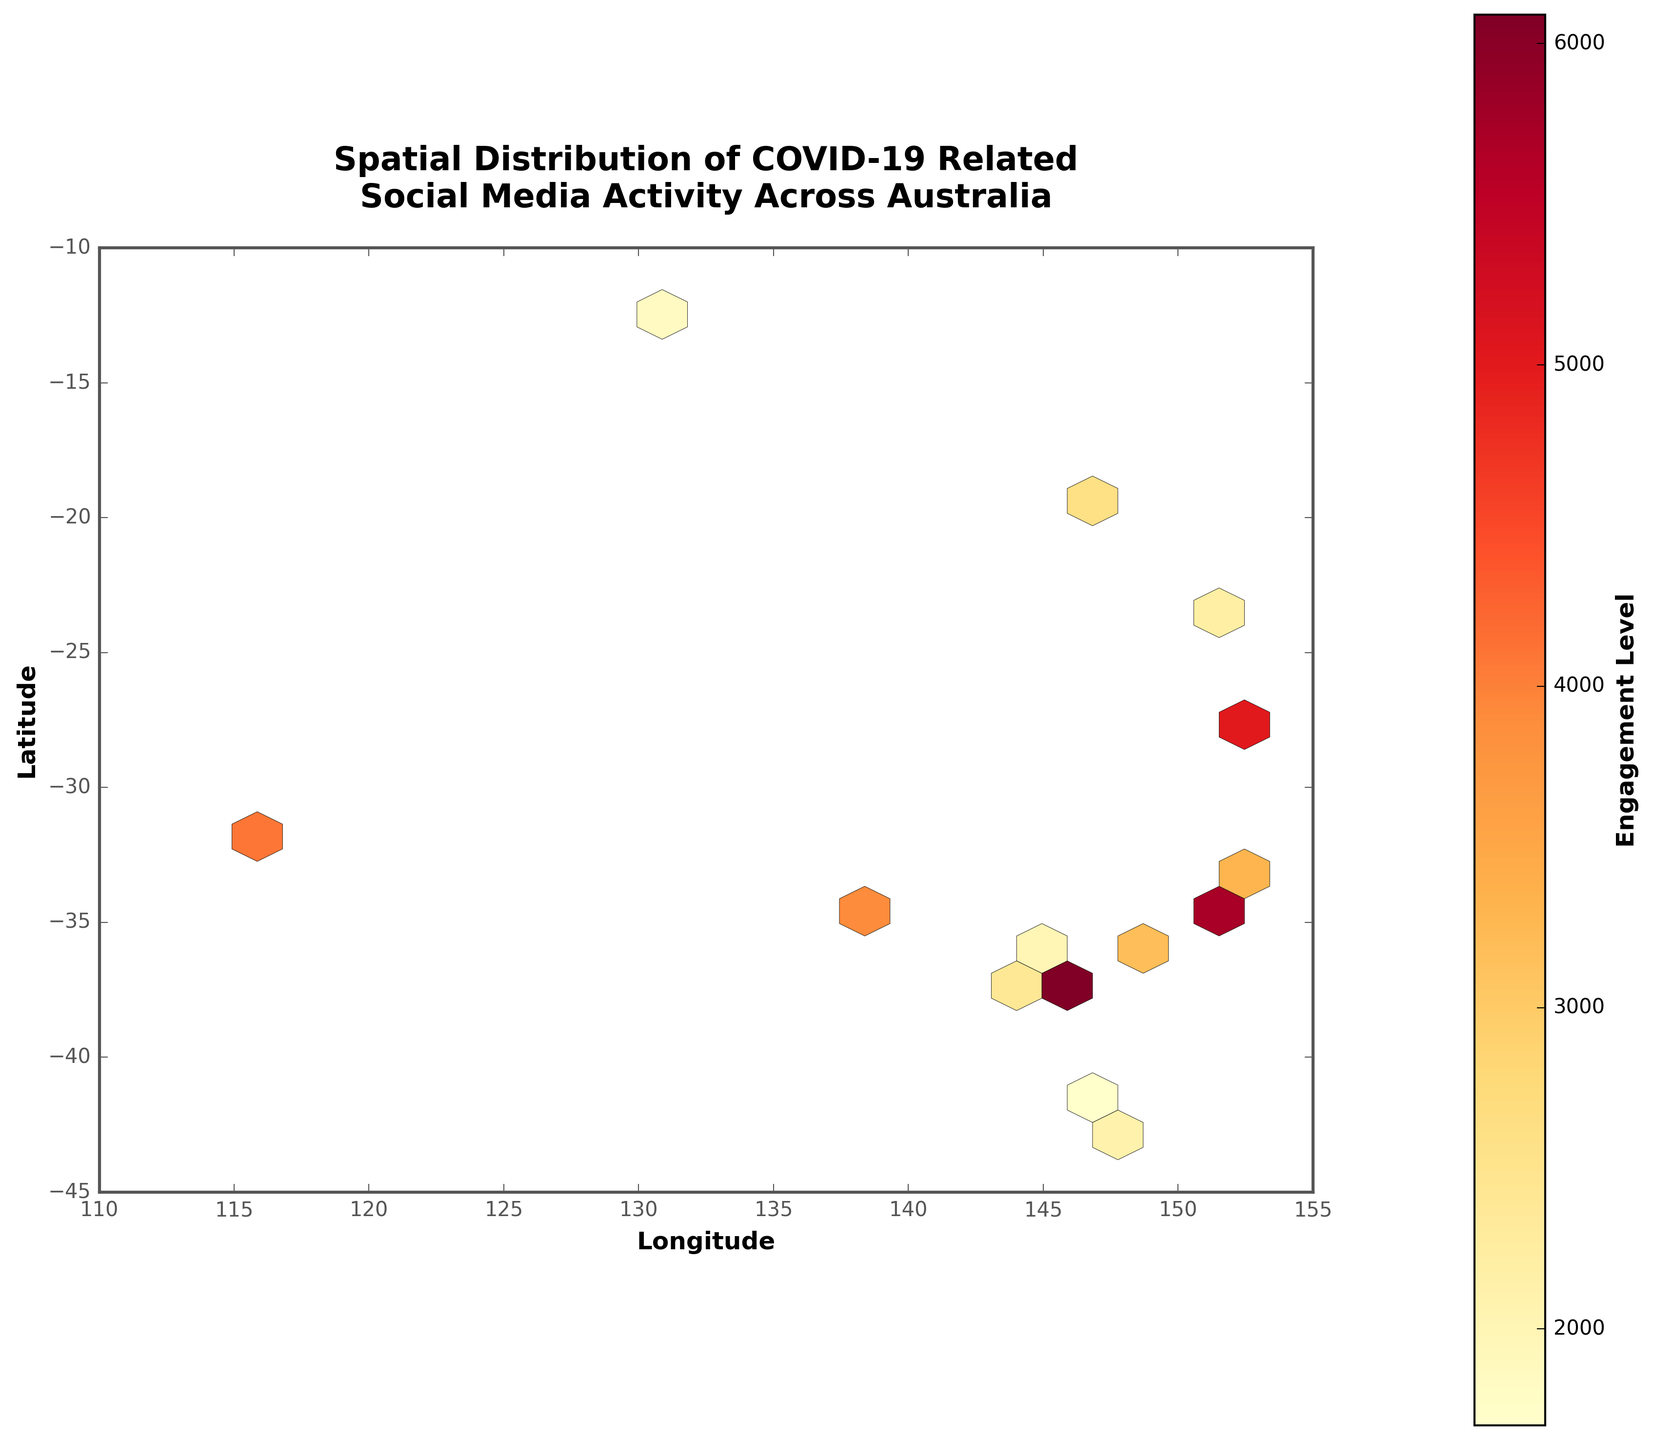What is the title of the plot? The title of the plot is displayed at the top center of the figure, using a larger font size and bold text for emphasis.
Answer: Spatial Distribution of COVID-19 Related Social Media Activity Across Australia What information does the color of the hexagons represent? The color scale represents the engagement levels, with different shades indicating varying levels as denoted by the color bar on the right side of the plot.
Answer: Engagement levels Which latitude and longitude cover the majority of high engagement levels? The highest engagement levels seem to be within the region around Sydney, which corresponds approximately to a latitude of -33.8688 and a longitude of 151.2093.
Answer: Latitude: -33.8688, Longitude: 151.2093 What is the range of the engagement level as shown in the color bar? The range of engagement levels is indicated by the color bar, which transitions from light to dark shades. The lower end is around 1,700 and the upper end is around 8,750.
Answer: 1,700 to 8,750 What does a darker hexagon indicate compared to a lighter hexagon? Darker hexagons represent higher engagement levels, while lighter hexagons represent lower engagement levels, as per the color bar’s gradient.
Answer: Higher engagement levels How many cities show engagement levels higher than 5000? By referring to the engagement levels of individual data points, we identify cities with engagement levels above 5000: Sydney (both entries), Melbourne, Brisbane, and Perth.
Answer: 5 cities Which area has the least engagement level? The area with the least engagement level is represented by the lightest hexagon, located near Darwin with an engagement level of 1850.
Answer: Darwin What similarities can you observe between the cities of Melbourne and Sydney in terms of engagement distribution on the plot? Both Melbourne and Sydney have multiple hexagons indicating high engagement levels, suggesting these cities have similar strong engagement distributions.
Answer: High engagement distribution Which city has a lower engagement level, Canberra or Hobart? By comparing the engagement levels of the two cities, Canberra is shown at 3450 while Hobart is shown at 2100. Thus, Hobart has a lower engagement level.
Answer: Hobart Are there areas with medium engagement levels between 3000 to 4000, and where are they located? Hexagons with engagement levels between 3000 to 4000 include those around cities such as Newcastle, Geelong, Gold Coast, and a second entry for Perth, identifiable from their respective engagement values and hexagon colors.
Answer: Newcastle, Geelong, Gold Coast 